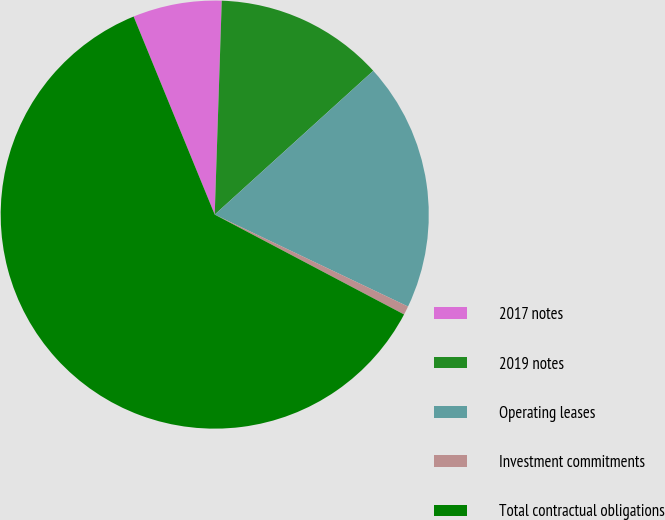<chart> <loc_0><loc_0><loc_500><loc_500><pie_chart><fcel>2017 notes<fcel>2019 notes<fcel>Operating leases<fcel>Investment commitments<fcel>Total contractual obligations<nl><fcel>6.71%<fcel>12.75%<fcel>18.79%<fcel>0.66%<fcel>61.09%<nl></chart> 